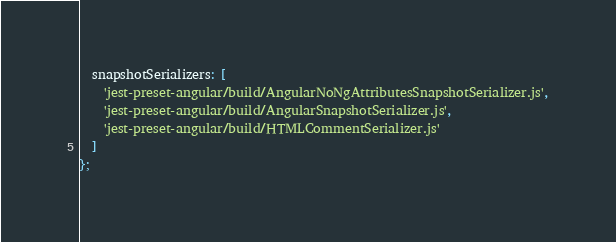Convert code to text. <code><loc_0><loc_0><loc_500><loc_500><_JavaScript_>  snapshotSerializers: [
    'jest-preset-angular/build/AngularNoNgAttributesSnapshotSerializer.js',
    'jest-preset-angular/build/AngularSnapshotSerializer.js',
    'jest-preset-angular/build/HTMLCommentSerializer.js'
  ]
};
</code> 